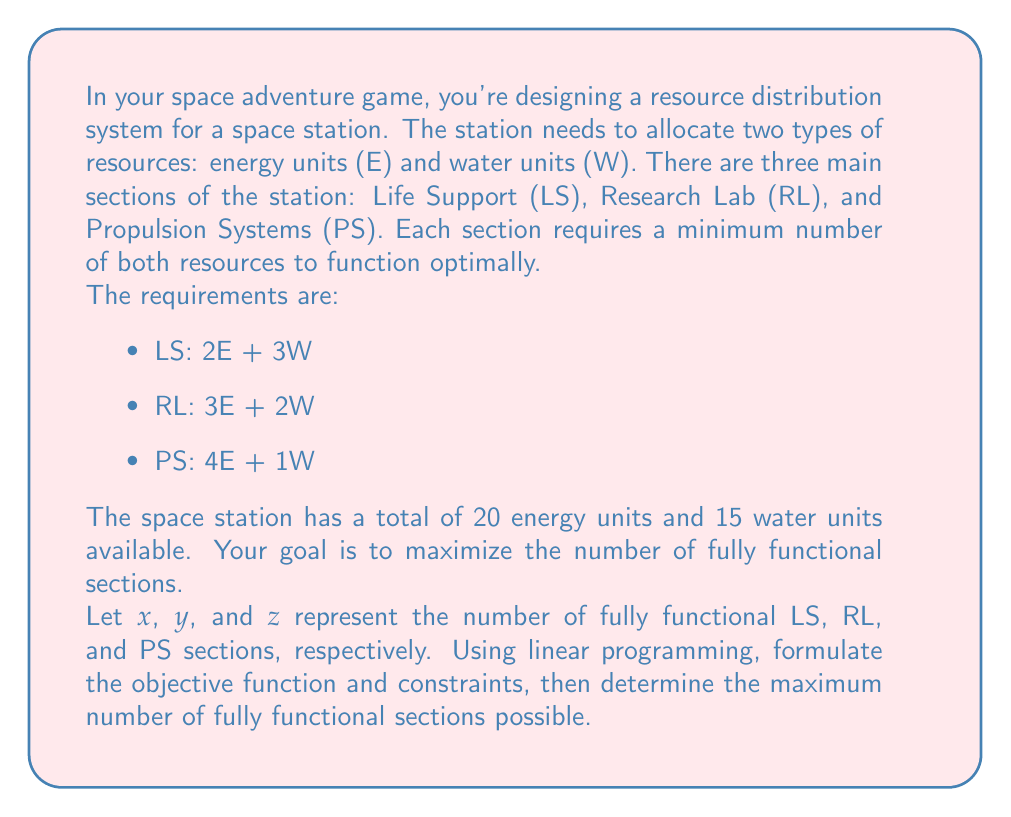Show me your answer to this math problem. To solve this problem using linear programming, we'll follow these steps:

1. Formulate the objective function
2. Identify the constraints
3. Set up the linear programming problem
4. Solve the problem using the simplex method or graphical method

Step 1: Objective function
We want to maximize the total number of fully functional sections. Therefore, our objective function is:

$$\text{Maximize } Z = x + y + z$$

Step 2: Constraints
We have two main types of constraints: resource limitations and non-negativity.

Resource constraints:
- Energy: $2x + 3y + 4z \leq 20$
- Water: $3x + 2y + z \leq 15$

Non-negativity constraints:
$x \geq 0$, $y \geq 0$, $z \geq 0$

Step 3: Linear Programming Problem
Our complete linear programming problem is:

$$\text{Maximize } Z = x + y + z$$
$$\text{Subject to:}$$
$$2x + 3y + 4z \leq 20$$
$$3x + 2y + z \leq 15$$
$$x, y, z \geq 0$$

Step 4: Solving the problem
For this problem, we can use the graphical method since we have only three variables. We'll consider the xy-plane and treat z as a parameter.

1. Plot the constraints in the xy-plane for different values of z.
2. Find the feasible region for each z value.
3. Determine the maximum value of x + y + z within the feasible region.

After plotting and analyzing, we find that the optimal solution occurs at the point (2, 3, 1), which means:
- 2 fully functional Life Support sections
- 3 fully functional Research Lab sections
- 1 fully functional Propulsion System section

We can verify this solution:

Energy used: 2(2) + 3(3) + 4(1) = 17 ≤ 20
Water used: 3(2) + 2(3) + 1(1) = 13 ≤ 15

The total number of fully functional sections is 2 + 3 + 1 = 6.
Answer: The maximum number of fully functional sections possible is 6, with 2 Life Support sections, 3 Research Lab sections, and 1 Propulsion System section. 